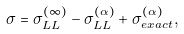Convert formula to latex. <formula><loc_0><loc_0><loc_500><loc_500>\sigma = \sigma _ { L L } ^ { ( \infty ) } - \sigma ^ { ( \alpha ) } _ { L L } + \sigma ^ { ( \alpha ) } _ { e x a c t } ,</formula> 